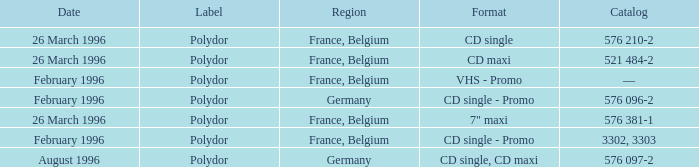Name the region with catalog of 576 097-2 Germany. 